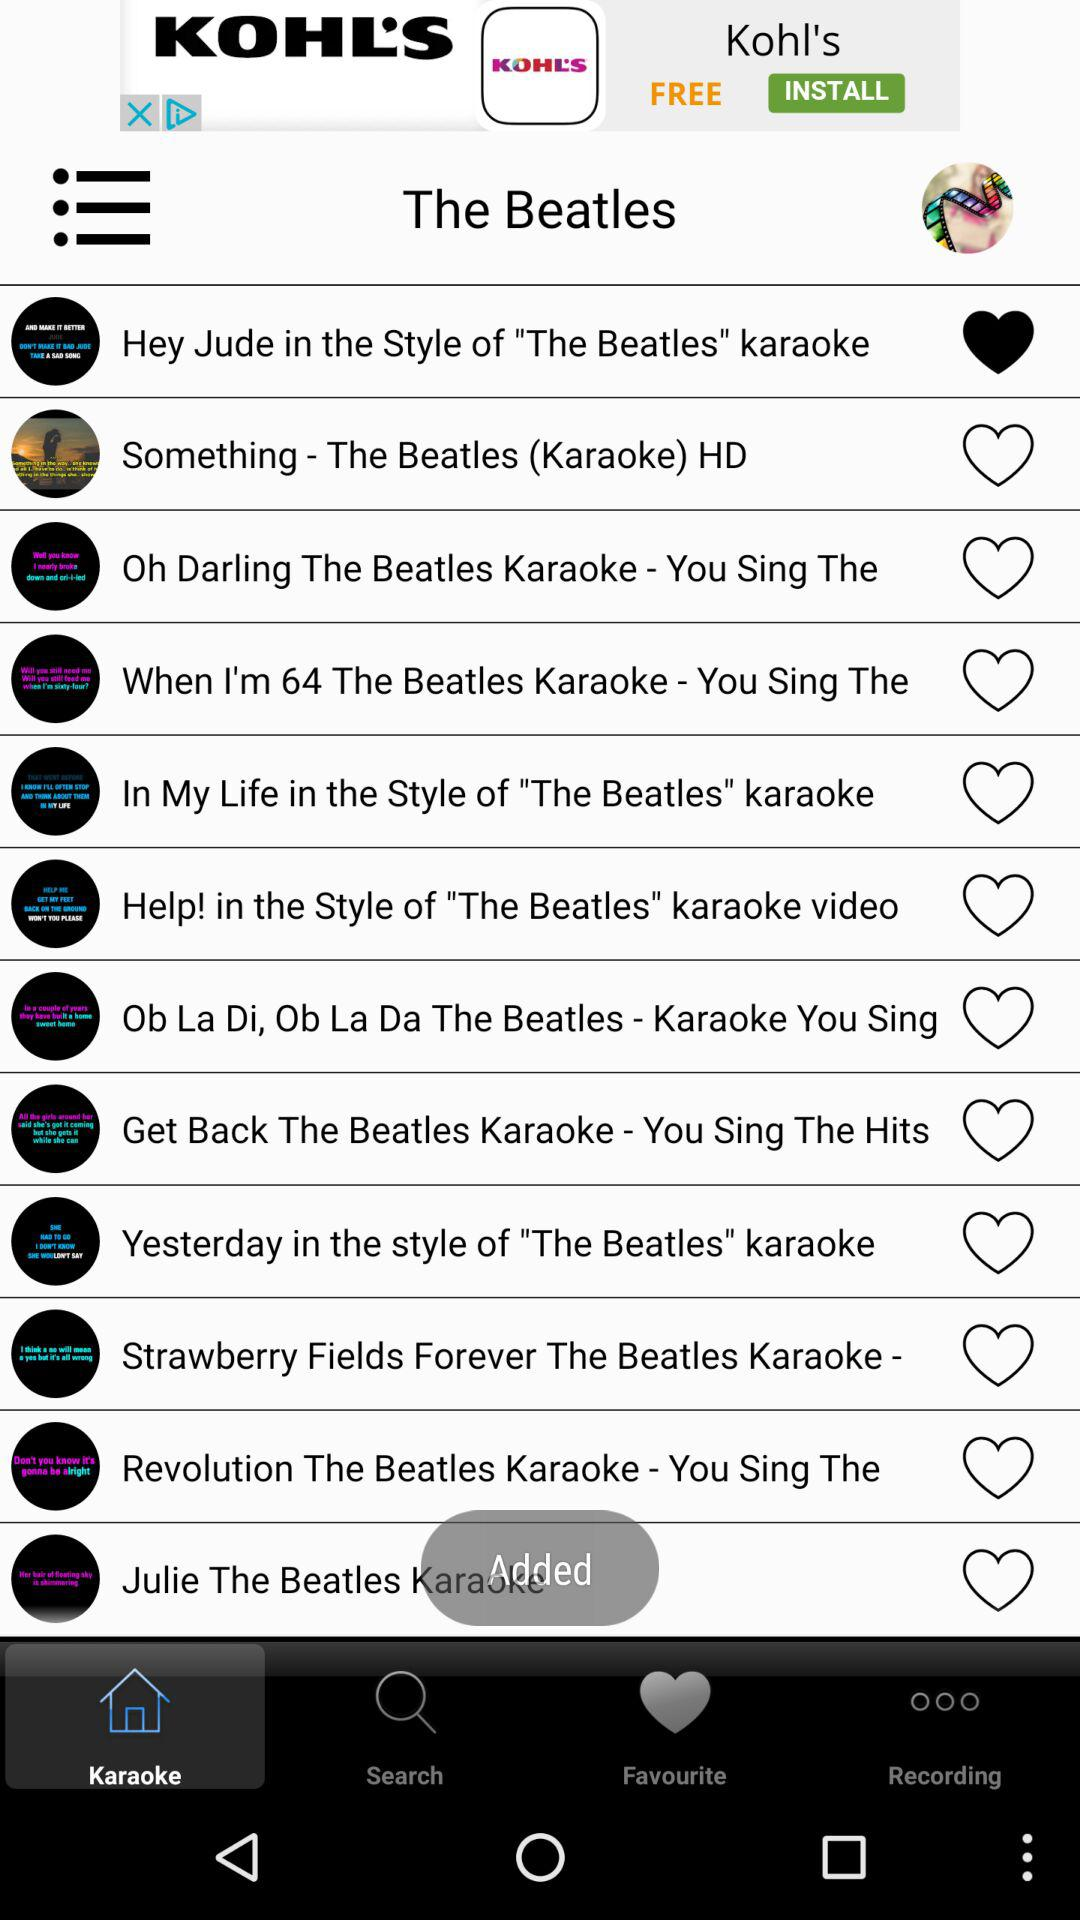Which option is marked as a favourite? The option that is marked as a favourite is "Hey Jude in the Style of "The Beatles" karaoke". 